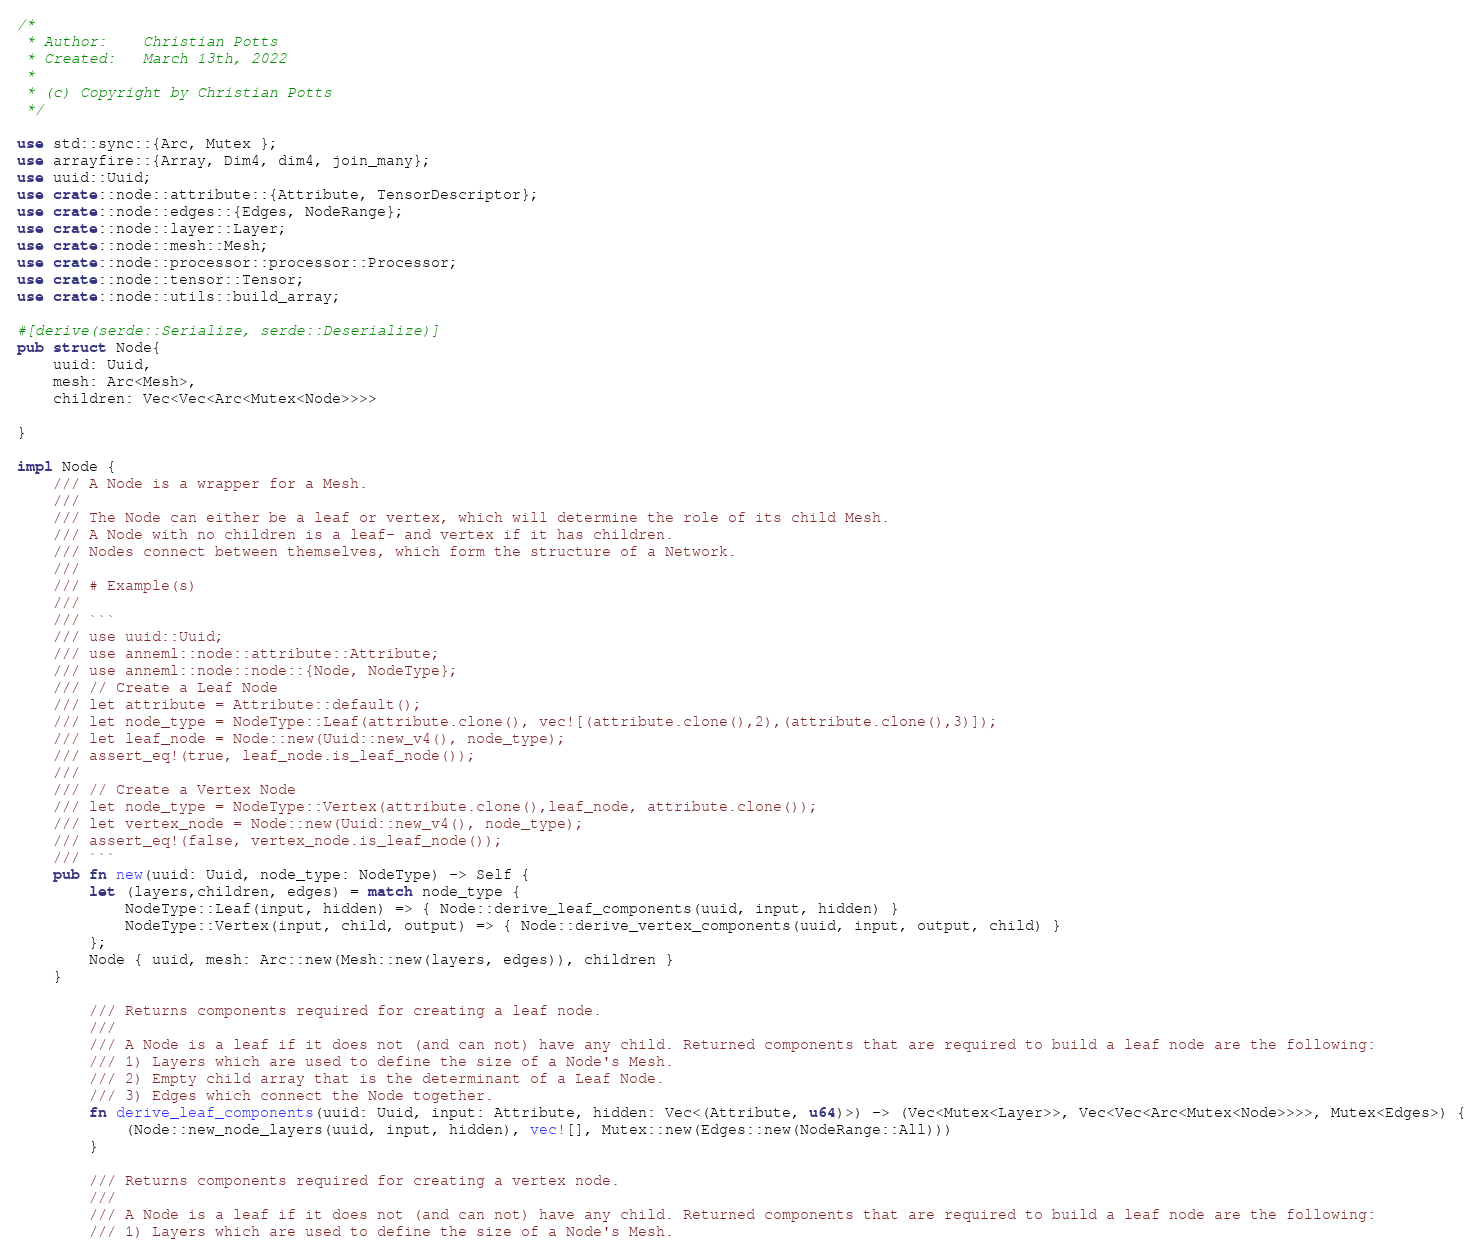Convert code to text. <code><loc_0><loc_0><loc_500><loc_500><_Rust_>/*
 * Author:    Christian Potts
 * Created:   March 13th, 2022
 *
 * (c) Copyright by Christian Potts
 */

use std::sync::{Arc, Mutex };
use arrayfire::{Array, Dim4, dim4, join_many};
use uuid::Uuid;
use crate::node::attribute::{Attribute, TensorDescriptor};
use crate::node::edges::{Edges, NodeRange};
use crate::node::layer::Layer;
use crate::node::mesh::Mesh;
use crate::node::processor::processor::Processor;
use crate::node::tensor::Tensor;
use crate::node::utils::build_array;

#[derive(serde::Serialize, serde::Deserialize)]
pub struct Node{
    uuid: Uuid,
    mesh: Arc<Mesh>,
    children: Vec<Vec<Arc<Mutex<Node>>>>

}

impl Node {
    /// A Node is a wrapper for a Mesh.
    ///
    /// The Node can either be a leaf or vertex, which will determine the role of its child Mesh.
    /// A Node with no children is a leaf- and vertex if it has children.
    /// Nodes connect between themselves, which form the structure of a Network.
    ///
    /// # Example(s)
    ///
    /// ```
    /// use uuid::Uuid;
    /// use anneml::node::attribute::Attribute;
    /// use anneml::node::node::{Node, NodeType};
    /// // Create a Leaf Node
    /// let attribute = Attribute::default();
    /// let node_type = NodeType::Leaf(attribute.clone(), vec![(attribute.clone(),2),(attribute.clone(),3)]);
    /// let leaf_node = Node::new(Uuid::new_v4(), node_type);
    /// assert_eq!(true, leaf_node.is_leaf_node());
    ///
    /// // Create a Vertex Node
    /// let node_type = NodeType::Vertex(attribute.clone(),leaf_node, attribute.clone());
    /// let vertex_node = Node::new(Uuid::new_v4(), node_type);
    /// assert_eq!(false, vertex_node.is_leaf_node());
    /// ```
    pub fn new(uuid: Uuid, node_type: NodeType) -> Self {
        let (layers,children, edges) = match node_type {
            NodeType::Leaf(input, hidden) => { Node::derive_leaf_components(uuid, input, hidden) }
            NodeType::Vertex(input, child, output) => { Node::derive_vertex_components(uuid, input, output, child) }
        };
        Node { uuid, mesh: Arc::new(Mesh::new(layers, edges)), children }
    }

        /// Returns components required for creating a leaf node.
        ///
        /// A Node is a leaf if it does not (and can not) have any child. Returned components that are required to build a leaf node are the following:
        /// 1) Layers which are used to define the size of a Node's Mesh.
        /// 2) Empty child array that is the determinant of a Leaf Node.
        /// 3) Edges which connect the Node together.
        fn derive_leaf_components(uuid: Uuid, input: Attribute, hidden: Vec<(Attribute, u64)>) -> (Vec<Mutex<Layer>>, Vec<Vec<Arc<Mutex<Node>>>>, Mutex<Edges>) {
            (Node::new_node_layers(uuid, input, hidden), vec![], Mutex::new(Edges::new(NodeRange::All)))
        }

        /// Returns components required for creating a vertex node.
        ///
        /// A Node is a leaf if it does not (and can not) have any child. Returned components that are required to build a leaf node are the following:
        /// 1) Layers which are used to define the size of a Node's Mesh.</code> 